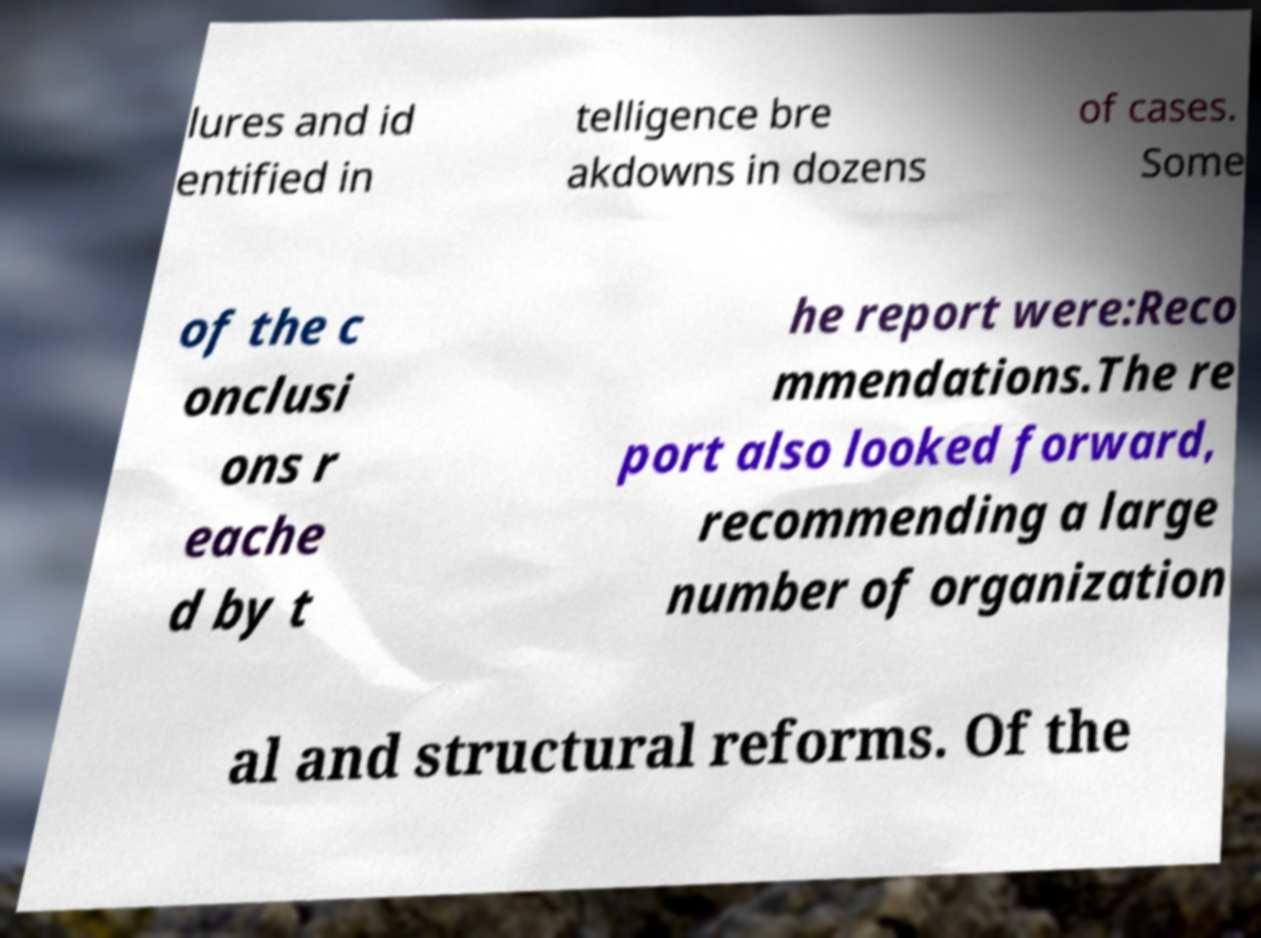For documentation purposes, I need the text within this image transcribed. Could you provide that? lures and id entified in telligence bre akdowns in dozens of cases. Some of the c onclusi ons r eache d by t he report were:Reco mmendations.The re port also looked forward, recommending a large number of organization al and structural reforms. Of the 